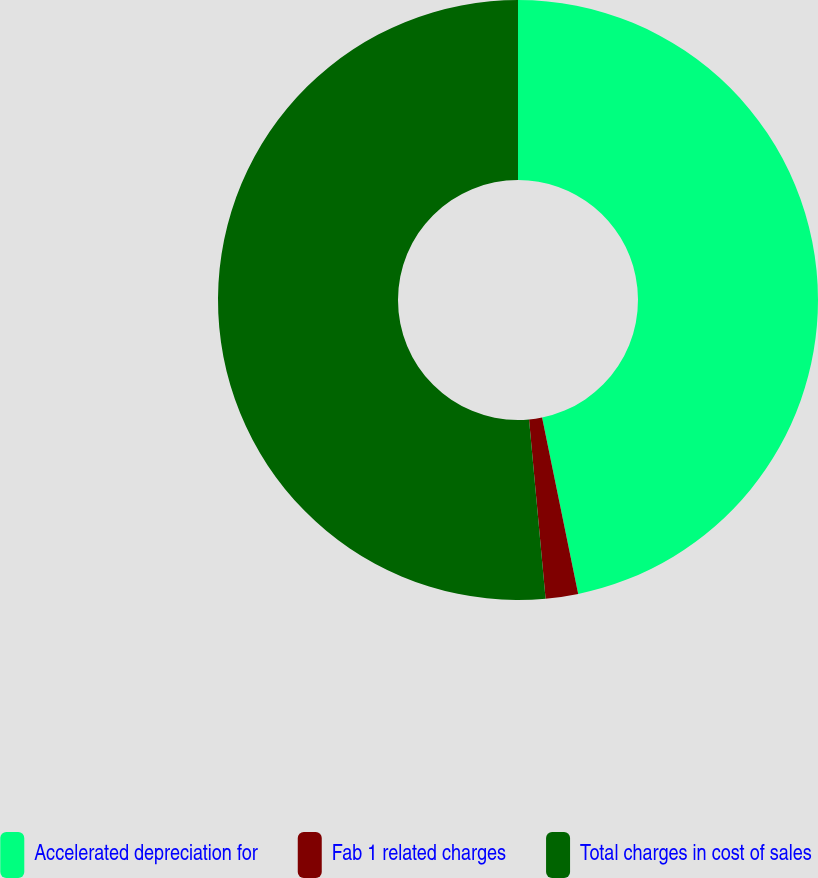Convert chart. <chart><loc_0><loc_0><loc_500><loc_500><pie_chart><fcel>Accelerated depreciation for<fcel>Fab 1 related charges<fcel>Total charges in cost of sales<nl><fcel>46.78%<fcel>1.75%<fcel>51.46%<nl></chart> 